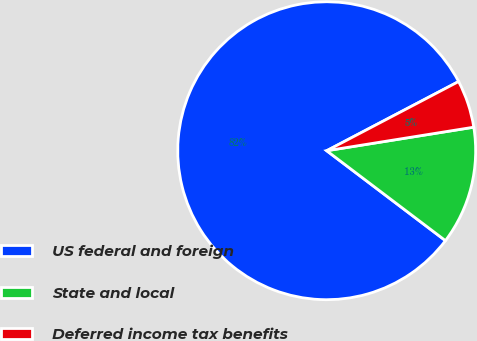<chart> <loc_0><loc_0><loc_500><loc_500><pie_chart><fcel>US federal and foreign<fcel>State and local<fcel>Deferred income tax benefits<nl><fcel>82.0%<fcel>12.84%<fcel>5.16%<nl></chart> 